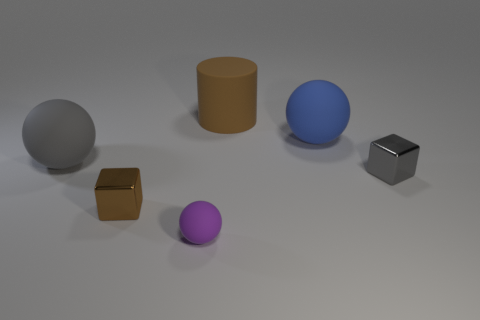Add 3 spheres. How many objects exist? 9 Subtract all cylinders. How many objects are left? 5 Subtract 0 cyan balls. How many objects are left? 6 Subtract all purple metallic cylinders. Subtract all large blue balls. How many objects are left? 5 Add 3 brown metal cubes. How many brown metal cubes are left? 4 Add 6 big gray balls. How many big gray balls exist? 7 